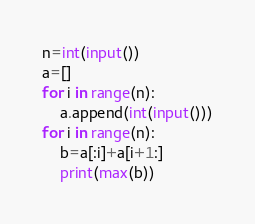Convert code to text. <code><loc_0><loc_0><loc_500><loc_500><_Python_>n=int(input())
a=[]
for i in range(n):
    a.append(int(input()))
for i in range(n):
    b=a[:i]+a[i+1:]
    print(max(b))
</code> 